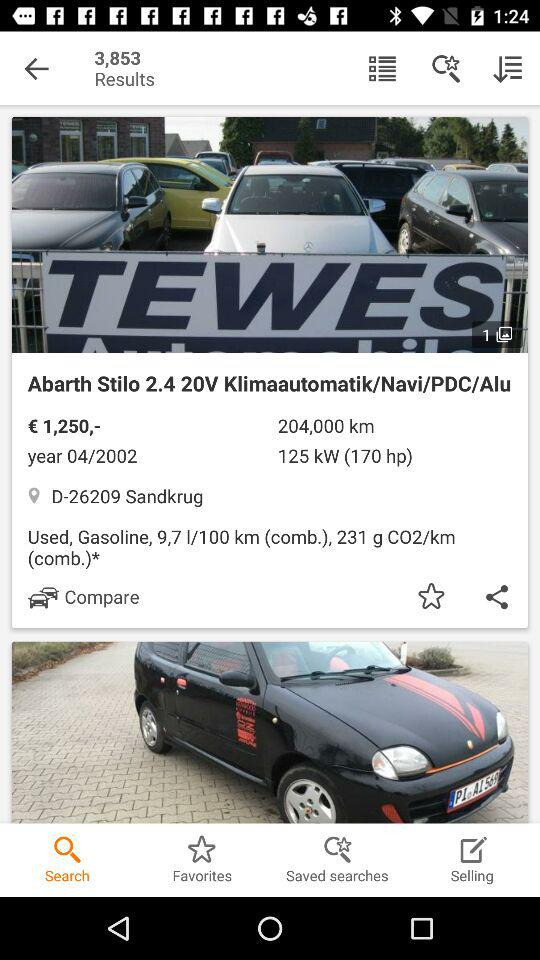What's the cost of the car? The cost of the car is €1,250. 